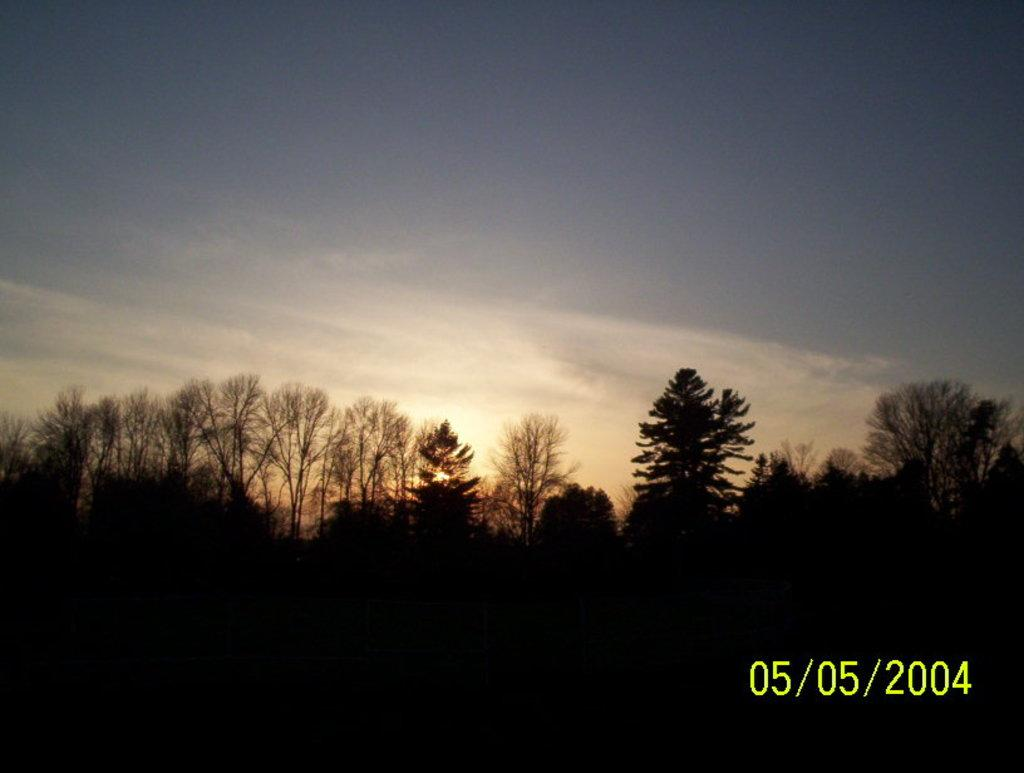What type of vegetation can be seen in the image? There are trees in the image. What part of the natural environment is visible in the image? The sky is visible in the background of the image. Where are the numbers located in the image? The numbers are in the bottom right corner of the image. What type of jar is being used to fly the airplane in the image? There is no airplane or jar present in the image. Where is the middle of the image located? The concept of a "middle" of the image is not applicable, as the image is a two-dimensional representation and does not have a physical center. 